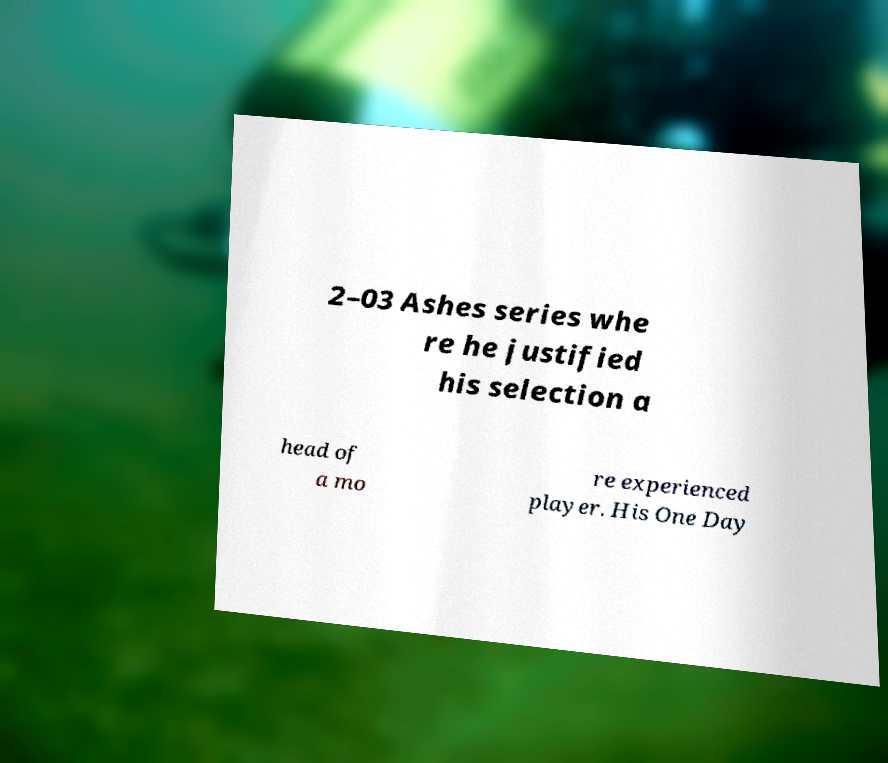Can you read and provide the text displayed in the image?This photo seems to have some interesting text. Can you extract and type it out for me? 2–03 Ashes series whe re he justified his selection a head of a mo re experienced player. His One Day 